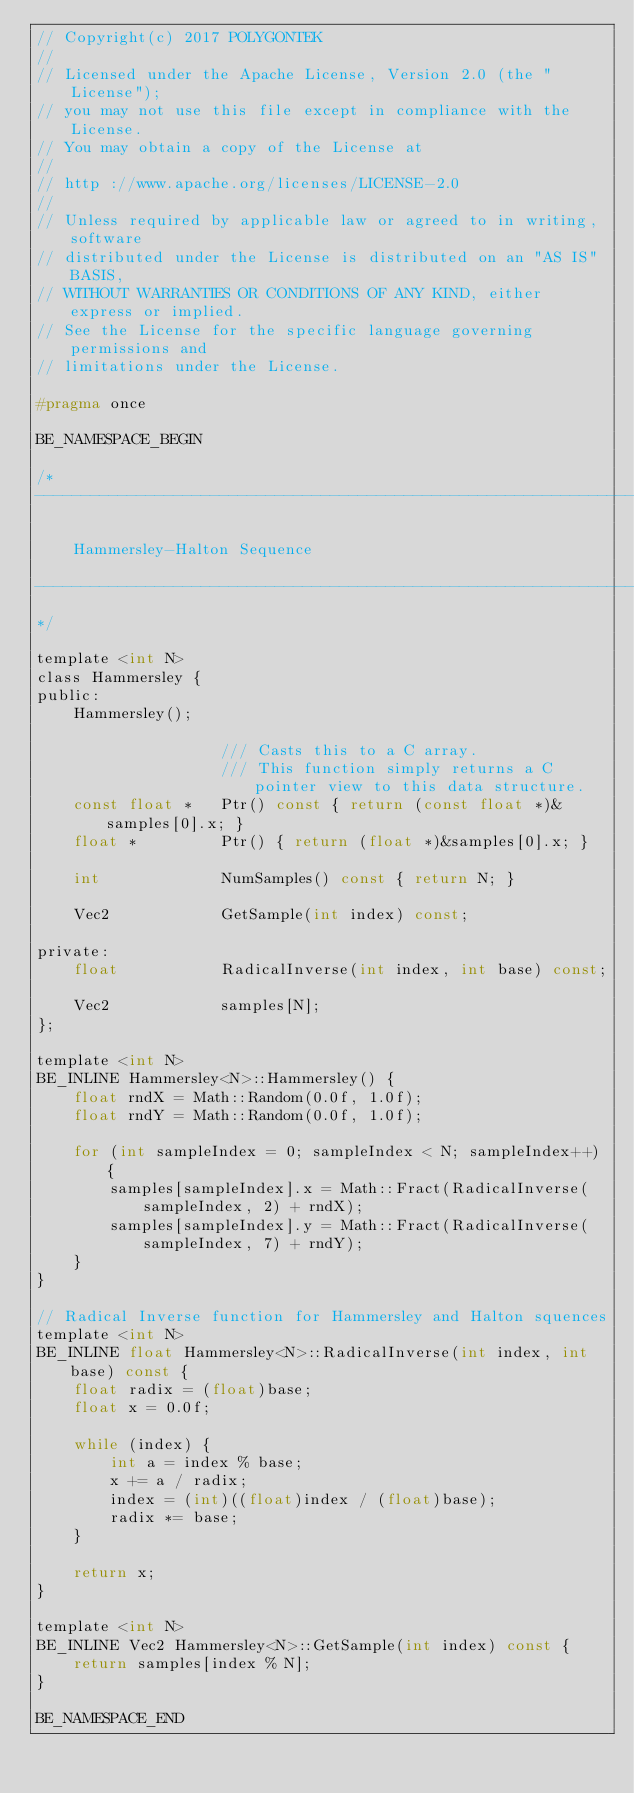Convert code to text. <code><loc_0><loc_0><loc_500><loc_500><_C_>// Copyright(c) 2017 POLYGONTEK
// 
// Licensed under the Apache License, Version 2.0 (the "License");
// you may not use this file except in compliance with the License.
// You may obtain a copy of the License at
// 
// http ://www.apache.org/licenses/LICENSE-2.0
// 
// Unless required by applicable law or agreed to in writing, software
// distributed under the License is distributed on an "AS IS" BASIS,
// WITHOUT WARRANTIES OR CONDITIONS OF ANY KIND, either express or implied.
// See the License for the specific language governing permissions and
// limitations under the License.

#pragma once

BE_NAMESPACE_BEGIN

/*
-------------------------------------------------------------------------------

    Hammersley-Halton Sequence

-------------------------------------------------------------------------------
*/

template <int N>
class Hammersley {
public:
    Hammersley();

                    /// Casts this to a C array.
                    /// This function simply returns a C pointer view to this data structure.
    const float *   Ptr() const { return (const float *)&samples[0].x; }
    float *         Ptr() { return (float *)&samples[0].x; }

    int             NumSamples() const { return N; }

    Vec2            GetSample(int index) const;

private:
    float           RadicalInverse(int index, int base) const;

    Vec2            samples[N];
};

template <int N>
BE_INLINE Hammersley<N>::Hammersley() {
    float rndX = Math::Random(0.0f, 1.0f);
    float rndY = Math::Random(0.0f, 1.0f);

    for (int sampleIndex = 0; sampleIndex < N; sampleIndex++) {
        samples[sampleIndex].x = Math::Fract(RadicalInverse(sampleIndex, 2) + rndX);
        samples[sampleIndex].y = Math::Fract(RadicalInverse(sampleIndex, 7) + rndY);
    }
}

// Radical Inverse function for Hammersley and Halton squences
template <int N>
BE_INLINE float Hammersley<N>::RadicalInverse(int index, int base) const {
    float radix = (float)base;
    float x = 0.0f;

    while (index) {
        int a = index % base;
        x += a / radix;
        index = (int)((float)index / (float)base);
        radix *= base;
    }

    return x;
}

template <int N>
BE_INLINE Vec2 Hammersley<N>::GetSample(int index) const {
    return samples[index % N];
}

BE_NAMESPACE_END</code> 